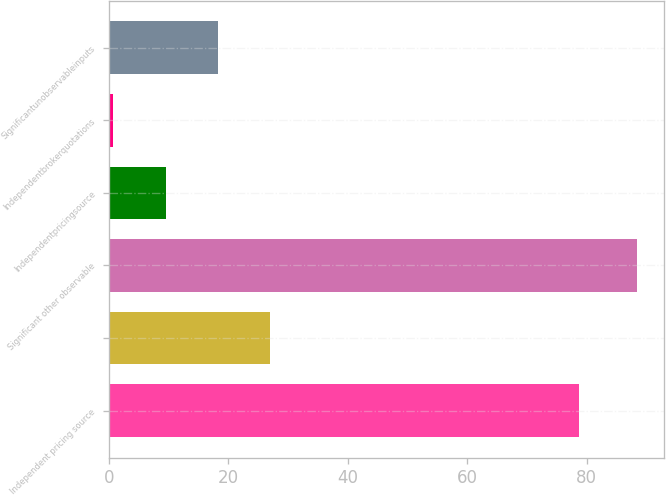Convert chart to OTSL. <chart><loc_0><loc_0><loc_500><loc_500><bar_chart><fcel>Independent pricing source<fcel>Unnamed: 1<fcel>Significant other observable<fcel>Independentpricingsource<fcel>Independentbrokerquotations<fcel>Significantunobservableinputs<nl><fcel>78.7<fcel>27.04<fcel>88.5<fcel>9.48<fcel>0.7<fcel>18.26<nl></chart> 